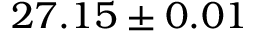Convert formula to latex. <formula><loc_0><loc_0><loc_500><loc_500>2 7 . 1 5 \pm 0 . 0 1</formula> 